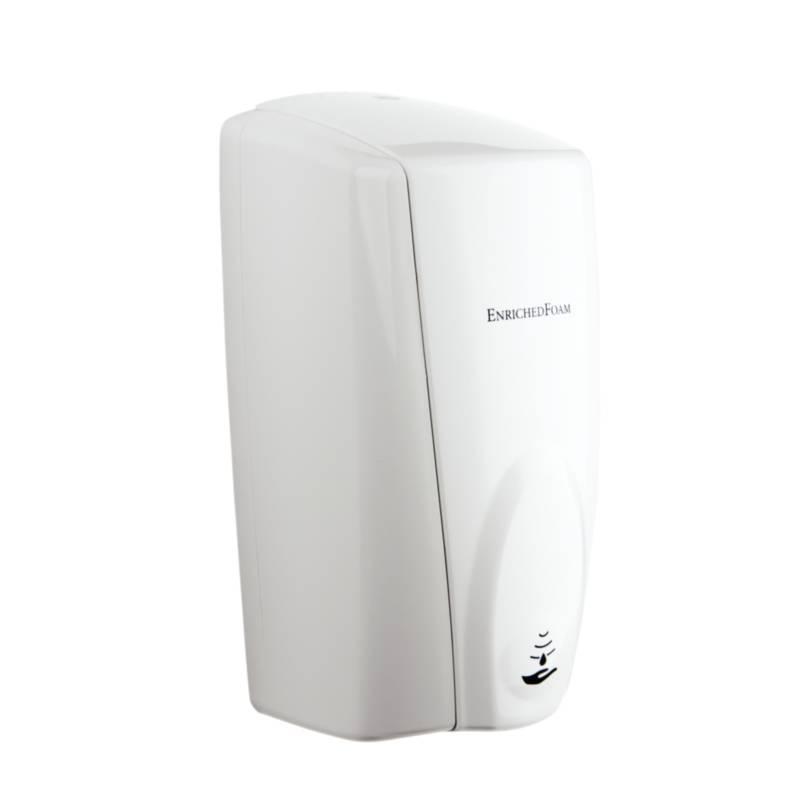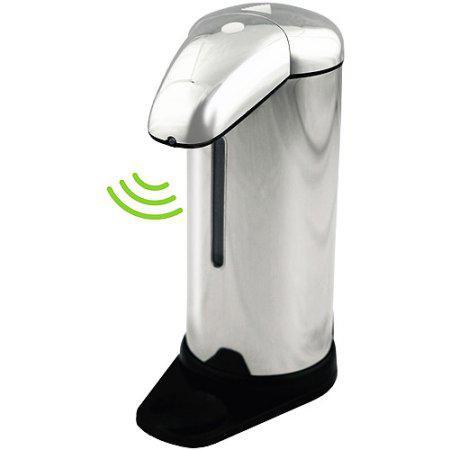The first image is the image on the left, the second image is the image on the right. For the images displayed, is the sentence "The image on the right contains a human hand." factually correct? Answer yes or no. No. The first image is the image on the left, the second image is the image on the right. For the images displayed, is the sentence "There is a human hand in the image on the left." factually correct? Answer yes or no. No. 